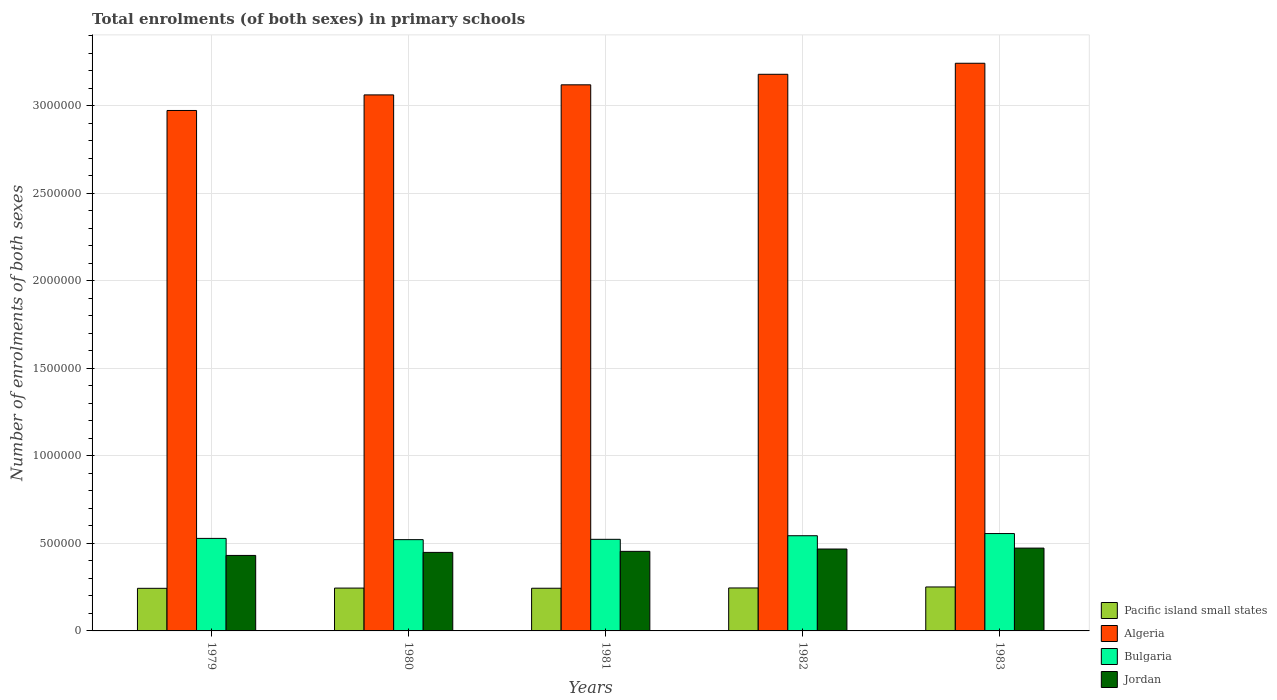How many groups of bars are there?
Make the answer very short. 5. Are the number of bars per tick equal to the number of legend labels?
Ensure brevity in your answer.  Yes. How many bars are there on the 4th tick from the left?
Make the answer very short. 4. How many bars are there on the 4th tick from the right?
Your response must be concise. 4. What is the label of the 5th group of bars from the left?
Your answer should be very brief. 1983. In how many cases, is the number of bars for a given year not equal to the number of legend labels?
Offer a terse response. 0. What is the number of enrolments in primary schools in Bulgaria in 1981?
Ensure brevity in your answer.  5.23e+05. Across all years, what is the maximum number of enrolments in primary schools in Algeria?
Your response must be concise. 3.24e+06. Across all years, what is the minimum number of enrolments in primary schools in Pacific island small states?
Your response must be concise. 2.43e+05. In which year was the number of enrolments in primary schools in Algeria minimum?
Offer a terse response. 1979. What is the total number of enrolments in primary schools in Algeria in the graph?
Offer a very short reply. 1.56e+07. What is the difference between the number of enrolments in primary schools in Algeria in 1981 and that in 1982?
Provide a succinct answer. -6.01e+04. What is the difference between the number of enrolments in primary schools in Jordan in 1982 and the number of enrolments in primary schools in Algeria in 1980?
Provide a succinct answer. -2.59e+06. What is the average number of enrolments in primary schools in Algeria per year?
Your answer should be compact. 3.11e+06. In the year 1980, what is the difference between the number of enrolments in primary schools in Jordan and number of enrolments in primary schools in Pacific island small states?
Make the answer very short. 2.04e+05. What is the ratio of the number of enrolments in primary schools in Jordan in 1979 to that in 1983?
Offer a very short reply. 0.91. Is the number of enrolments in primary schools in Algeria in 1981 less than that in 1983?
Provide a short and direct response. Yes. What is the difference between the highest and the second highest number of enrolments in primary schools in Jordan?
Provide a succinct answer. 5331. What is the difference between the highest and the lowest number of enrolments in primary schools in Pacific island small states?
Provide a succinct answer. 7791.62. In how many years, is the number of enrolments in primary schools in Bulgaria greater than the average number of enrolments in primary schools in Bulgaria taken over all years?
Give a very brief answer. 2. Is the sum of the number of enrolments in primary schools in Jordan in 1981 and 1982 greater than the maximum number of enrolments in primary schools in Bulgaria across all years?
Offer a very short reply. Yes. What does the 2nd bar from the left in 1980 represents?
Provide a succinct answer. Algeria. What does the 4th bar from the right in 1983 represents?
Offer a terse response. Pacific island small states. How many bars are there?
Your answer should be very brief. 20. Are all the bars in the graph horizontal?
Make the answer very short. No. What is the difference between two consecutive major ticks on the Y-axis?
Keep it short and to the point. 5.00e+05. Does the graph contain any zero values?
Your answer should be very brief. No. Where does the legend appear in the graph?
Ensure brevity in your answer.  Bottom right. How many legend labels are there?
Offer a terse response. 4. How are the legend labels stacked?
Your answer should be compact. Vertical. What is the title of the graph?
Make the answer very short. Total enrolments (of both sexes) in primary schools. What is the label or title of the X-axis?
Your answer should be compact. Years. What is the label or title of the Y-axis?
Your answer should be compact. Number of enrolments of both sexes. What is the Number of enrolments of both sexes of Pacific island small states in 1979?
Keep it short and to the point. 2.43e+05. What is the Number of enrolments of both sexes in Algeria in 1979?
Your answer should be compact. 2.97e+06. What is the Number of enrolments of both sexes of Bulgaria in 1979?
Offer a terse response. 5.28e+05. What is the Number of enrolments of both sexes in Jordan in 1979?
Provide a succinct answer. 4.31e+05. What is the Number of enrolments of both sexes in Pacific island small states in 1980?
Your response must be concise. 2.45e+05. What is the Number of enrolments of both sexes of Algeria in 1980?
Your answer should be compact. 3.06e+06. What is the Number of enrolments of both sexes in Bulgaria in 1980?
Ensure brevity in your answer.  5.21e+05. What is the Number of enrolments of both sexes in Jordan in 1980?
Provide a succinct answer. 4.48e+05. What is the Number of enrolments of both sexes of Pacific island small states in 1981?
Your response must be concise. 2.44e+05. What is the Number of enrolments of both sexes of Algeria in 1981?
Offer a terse response. 3.12e+06. What is the Number of enrolments of both sexes in Bulgaria in 1981?
Your response must be concise. 5.23e+05. What is the Number of enrolments of both sexes of Jordan in 1981?
Your response must be concise. 4.54e+05. What is the Number of enrolments of both sexes of Pacific island small states in 1982?
Provide a succinct answer. 2.45e+05. What is the Number of enrolments of both sexes of Algeria in 1982?
Provide a succinct answer. 3.18e+06. What is the Number of enrolments of both sexes of Bulgaria in 1982?
Your response must be concise. 5.44e+05. What is the Number of enrolments of both sexes in Jordan in 1982?
Your answer should be very brief. 4.68e+05. What is the Number of enrolments of both sexes in Pacific island small states in 1983?
Provide a succinct answer. 2.51e+05. What is the Number of enrolments of both sexes in Algeria in 1983?
Make the answer very short. 3.24e+06. What is the Number of enrolments of both sexes in Bulgaria in 1983?
Provide a succinct answer. 5.56e+05. What is the Number of enrolments of both sexes in Jordan in 1983?
Keep it short and to the point. 4.73e+05. Across all years, what is the maximum Number of enrolments of both sexes of Pacific island small states?
Offer a terse response. 2.51e+05. Across all years, what is the maximum Number of enrolments of both sexes of Algeria?
Your response must be concise. 3.24e+06. Across all years, what is the maximum Number of enrolments of both sexes in Bulgaria?
Offer a terse response. 5.56e+05. Across all years, what is the maximum Number of enrolments of both sexes in Jordan?
Your answer should be very brief. 4.73e+05. Across all years, what is the minimum Number of enrolments of both sexes in Pacific island small states?
Your answer should be very brief. 2.43e+05. Across all years, what is the minimum Number of enrolments of both sexes in Algeria?
Your response must be concise. 2.97e+06. Across all years, what is the minimum Number of enrolments of both sexes of Bulgaria?
Your response must be concise. 5.21e+05. Across all years, what is the minimum Number of enrolments of both sexes of Jordan?
Make the answer very short. 4.31e+05. What is the total Number of enrolments of both sexes of Pacific island small states in the graph?
Offer a very short reply. 1.23e+06. What is the total Number of enrolments of both sexes of Algeria in the graph?
Make the answer very short. 1.56e+07. What is the total Number of enrolments of both sexes of Bulgaria in the graph?
Your answer should be very brief. 2.67e+06. What is the total Number of enrolments of both sexes in Jordan in the graph?
Offer a very short reply. 2.27e+06. What is the difference between the Number of enrolments of both sexes in Pacific island small states in 1979 and that in 1980?
Your answer should be compact. -1357.97. What is the difference between the Number of enrolments of both sexes of Algeria in 1979 and that in 1980?
Keep it short and to the point. -8.90e+04. What is the difference between the Number of enrolments of both sexes of Bulgaria in 1979 and that in 1980?
Offer a very short reply. 7083. What is the difference between the Number of enrolments of both sexes in Jordan in 1979 and that in 1980?
Provide a short and direct response. -1.73e+04. What is the difference between the Number of enrolments of both sexes of Pacific island small states in 1979 and that in 1981?
Provide a succinct answer. -450.34. What is the difference between the Number of enrolments of both sexes in Algeria in 1979 and that in 1981?
Offer a terse response. -1.47e+05. What is the difference between the Number of enrolments of both sexes in Bulgaria in 1979 and that in 1981?
Provide a succinct answer. 5206. What is the difference between the Number of enrolments of both sexes in Jordan in 1979 and that in 1981?
Make the answer very short. -2.33e+04. What is the difference between the Number of enrolments of both sexes in Pacific island small states in 1979 and that in 1982?
Offer a terse response. -2059.73. What is the difference between the Number of enrolments of both sexes in Algeria in 1979 and that in 1982?
Your answer should be very brief. -2.07e+05. What is the difference between the Number of enrolments of both sexes of Bulgaria in 1979 and that in 1982?
Give a very brief answer. -1.53e+04. What is the difference between the Number of enrolments of both sexes in Jordan in 1979 and that in 1982?
Your answer should be very brief. -3.66e+04. What is the difference between the Number of enrolments of both sexes of Pacific island small states in 1979 and that in 1983?
Ensure brevity in your answer.  -7791.62. What is the difference between the Number of enrolments of both sexes in Algeria in 1979 and that in 1983?
Give a very brief answer. -2.70e+05. What is the difference between the Number of enrolments of both sexes of Bulgaria in 1979 and that in 1983?
Provide a succinct answer. -2.77e+04. What is the difference between the Number of enrolments of both sexes in Jordan in 1979 and that in 1983?
Provide a short and direct response. -4.19e+04. What is the difference between the Number of enrolments of both sexes in Pacific island small states in 1980 and that in 1981?
Your answer should be very brief. 907.62. What is the difference between the Number of enrolments of both sexes in Algeria in 1980 and that in 1981?
Your answer should be very brief. -5.76e+04. What is the difference between the Number of enrolments of both sexes in Bulgaria in 1980 and that in 1981?
Provide a short and direct response. -1877. What is the difference between the Number of enrolments of both sexes of Jordan in 1980 and that in 1981?
Ensure brevity in your answer.  -5980. What is the difference between the Number of enrolments of both sexes in Pacific island small states in 1980 and that in 1982?
Make the answer very short. -701.77. What is the difference between the Number of enrolments of both sexes in Algeria in 1980 and that in 1982?
Provide a succinct answer. -1.18e+05. What is the difference between the Number of enrolments of both sexes of Bulgaria in 1980 and that in 1982?
Your answer should be very brief. -2.24e+04. What is the difference between the Number of enrolments of both sexes in Jordan in 1980 and that in 1982?
Keep it short and to the point. -1.93e+04. What is the difference between the Number of enrolments of both sexes in Pacific island small states in 1980 and that in 1983?
Your response must be concise. -6433.66. What is the difference between the Number of enrolments of both sexes in Algeria in 1980 and that in 1983?
Your answer should be very brief. -1.81e+05. What is the difference between the Number of enrolments of both sexes of Bulgaria in 1980 and that in 1983?
Provide a succinct answer. -3.48e+04. What is the difference between the Number of enrolments of both sexes of Jordan in 1980 and that in 1983?
Your answer should be compact. -2.46e+04. What is the difference between the Number of enrolments of both sexes of Pacific island small states in 1981 and that in 1982?
Provide a succinct answer. -1609.39. What is the difference between the Number of enrolments of both sexes in Algeria in 1981 and that in 1982?
Make the answer very short. -6.01e+04. What is the difference between the Number of enrolments of both sexes of Bulgaria in 1981 and that in 1982?
Provide a succinct answer. -2.05e+04. What is the difference between the Number of enrolments of both sexes in Jordan in 1981 and that in 1982?
Make the answer very short. -1.33e+04. What is the difference between the Number of enrolments of both sexes in Pacific island small states in 1981 and that in 1983?
Offer a very short reply. -7341.28. What is the difference between the Number of enrolments of both sexes of Algeria in 1981 and that in 1983?
Make the answer very short. -1.23e+05. What is the difference between the Number of enrolments of both sexes in Bulgaria in 1981 and that in 1983?
Offer a very short reply. -3.29e+04. What is the difference between the Number of enrolments of both sexes of Jordan in 1981 and that in 1983?
Your response must be concise. -1.86e+04. What is the difference between the Number of enrolments of both sexes in Pacific island small states in 1982 and that in 1983?
Ensure brevity in your answer.  -5731.89. What is the difference between the Number of enrolments of both sexes of Algeria in 1982 and that in 1983?
Make the answer very short. -6.30e+04. What is the difference between the Number of enrolments of both sexes of Bulgaria in 1982 and that in 1983?
Ensure brevity in your answer.  -1.24e+04. What is the difference between the Number of enrolments of both sexes in Jordan in 1982 and that in 1983?
Provide a short and direct response. -5331. What is the difference between the Number of enrolments of both sexes of Pacific island small states in 1979 and the Number of enrolments of both sexes of Algeria in 1980?
Your answer should be compact. -2.82e+06. What is the difference between the Number of enrolments of both sexes of Pacific island small states in 1979 and the Number of enrolments of both sexes of Bulgaria in 1980?
Provide a succinct answer. -2.78e+05. What is the difference between the Number of enrolments of both sexes in Pacific island small states in 1979 and the Number of enrolments of both sexes in Jordan in 1980?
Provide a short and direct response. -2.05e+05. What is the difference between the Number of enrolments of both sexes of Algeria in 1979 and the Number of enrolments of both sexes of Bulgaria in 1980?
Provide a succinct answer. 2.45e+06. What is the difference between the Number of enrolments of both sexes of Algeria in 1979 and the Number of enrolments of both sexes of Jordan in 1980?
Give a very brief answer. 2.52e+06. What is the difference between the Number of enrolments of both sexes of Bulgaria in 1979 and the Number of enrolments of both sexes of Jordan in 1980?
Provide a short and direct response. 8.00e+04. What is the difference between the Number of enrolments of both sexes of Pacific island small states in 1979 and the Number of enrolments of both sexes of Algeria in 1981?
Provide a short and direct response. -2.88e+06. What is the difference between the Number of enrolments of both sexes of Pacific island small states in 1979 and the Number of enrolments of both sexes of Bulgaria in 1981?
Provide a short and direct response. -2.80e+05. What is the difference between the Number of enrolments of both sexes of Pacific island small states in 1979 and the Number of enrolments of both sexes of Jordan in 1981?
Your answer should be compact. -2.11e+05. What is the difference between the Number of enrolments of both sexes in Algeria in 1979 and the Number of enrolments of both sexes in Bulgaria in 1981?
Your answer should be very brief. 2.45e+06. What is the difference between the Number of enrolments of both sexes of Algeria in 1979 and the Number of enrolments of both sexes of Jordan in 1981?
Make the answer very short. 2.52e+06. What is the difference between the Number of enrolments of both sexes in Bulgaria in 1979 and the Number of enrolments of both sexes in Jordan in 1981?
Give a very brief answer. 7.40e+04. What is the difference between the Number of enrolments of both sexes of Pacific island small states in 1979 and the Number of enrolments of both sexes of Algeria in 1982?
Provide a short and direct response. -2.94e+06. What is the difference between the Number of enrolments of both sexes of Pacific island small states in 1979 and the Number of enrolments of both sexes of Bulgaria in 1982?
Provide a short and direct response. -3.00e+05. What is the difference between the Number of enrolments of both sexes in Pacific island small states in 1979 and the Number of enrolments of both sexes in Jordan in 1982?
Offer a very short reply. -2.24e+05. What is the difference between the Number of enrolments of both sexes of Algeria in 1979 and the Number of enrolments of both sexes of Bulgaria in 1982?
Your response must be concise. 2.43e+06. What is the difference between the Number of enrolments of both sexes of Algeria in 1979 and the Number of enrolments of both sexes of Jordan in 1982?
Offer a terse response. 2.50e+06. What is the difference between the Number of enrolments of both sexes in Bulgaria in 1979 and the Number of enrolments of both sexes in Jordan in 1982?
Ensure brevity in your answer.  6.07e+04. What is the difference between the Number of enrolments of both sexes of Pacific island small states in 1979 and the Number of enrolments of both sexes of Algeria in 1983?
Your answer should be very brief. -3.00e+06. What is the difference between the Number of enrolments of both sexes of Pacific island small states in 1979 and the Number of enrolments of both sexes of Bulgaria in 1983?
Your response must be concise. -3.13e+05. What is the difference between the Number of enrolments of both sexes of Pacific island small states in 1979 and the Number of enrolments of both sexes of Jordan in 1983?
Ensure brevity in your answer.  -2.30e+05. What is the difference between the Number of enrolments of both sexes in Algeria in 1979 and the Number of enrolments of both sexes in Bulgaria in 1983?
Keep it short and to the point. 2.42e+06. What is the difference between the Number of enrolments of both sexes of Algeria in 1979 and the Number of enrolments of both sexes of Jordan in 1983?
Ensure brevity in your answer.  2.50e+06. What is the difference between the Number of enrolments of both sexes in Bulgaria in 1979 and the Number of enrolments of both sexes in Jordan in 1983?
Offer a terse response. 5.53e+04. What is the difference between the Number of enrolments of both sexes of Pacific island small states in 1980 and the Number of enrolments of both sexes of Algeria in 1981?
Ensure brevity in your answer.  -2.87e+06. What is the difference between the Number of enrolments of both sexes in Pacific island small states in 1980 and the Number of enrolments of both sexes in Bulgaria in 1981?
Provide a short and direct response. -2.79e+05. What is the difference between the Number of enrolments of both sexes of Pacific island small states in 1980 and the Number of enrolments of both sexes of Jordan in 1981?
Your response must be concise. -2.10e+05. What is the difference between the Number of enrolments of both sexes of Algeria in 1980 and the Number of enrolments of both sexes of Bulgaria in 1981?
Your answer should be compact. 2.54e+06. What is the difference between the Number of enrolments of both sexes of Algeria in 1980 and the Number of enrolments of both sexes of Jordan in 1981?
Offer a very short reply. 2.61e+06. What is the difference between the Number of enrolments of both sexes in Bulgaria in 1980 and the Number of enrolments of both sexes in Jordan in 1981?
Provide a short and direct response. 6.69e+04. What is the difference between the Number of enrolments of both sexes of Pacific island small states in 1980 and the Number of enrolments of both sexes of Algeria in 1982?
Offer a terse response. -2.93e+06. What is the difference between the Number of enrolments of both sexes of Pacific island small states in 1980 and the Number of enrolments of both sexes of Bulgaria in 1982?
Keep it short and to the point. -2.99e+05. What is the difference between the Number of enrolments of both sexes of Pacific island small states in 1980 and the Number of enrolments of both sexes of Jordan in 1982?
Make the answer very short. -2.23e+05. What is the difference between the Number of enrolments of both sexes in Algeria in 1980 and the Number of enrolments of both sexes in Bulgaria in 1982?
Your answer should be very brief. 2.52e+06. What is the difference between the Number of enrolments of both sexes of Algeria in 1980 and the Number of enrolments of both sexes of Jordan in 1982?
Make the answer very short. 2.59e+06. What is the difference between the Number of enrolments of both sexes in Bulgaria in 1980 and the Number of enrolments of both sexes in Jordan in 1982?
Your response must be concise. 5.36e+04. What is the difference between the Number of enrolments of both sexes in Pacific island small states in 1980 and the Number of enrolments of both sexes in Algeria in 1983?
Provide a succinct answer. -3.00e+06. What is the difference between the Number of enrolments of both sexes of Pacific island small states in 1980 and the Number of enrolments of both sexes of Bulgaria in 1983?
Give a very brief answer. -3.11e+05. What is the difference between the Number of enrolments of both sexes in Pacific island small states in 1980 and the Number of enrolments of both sexes in Jordan in 1983?
Provide a succinct answer. -2.28e+05. What is the difference between the Number of enrolments of both sexes in Algeria in 1980 and the Number of enrolments of both sexes in Bulgaria in 1983?
Keep it short and to the point. 2.51e+06. What is the difference between the Number of enrolments of both sexes in Algeria in 1980 and the Number of enrolments of both sexes in Jordan in 1983?
Your answer should be very brief. 2.59e+06. What is the difference between the Number of enrolments of both sexes of Bulgaria in 1980 and the Number of enrolments of both sexes of Jordan in 1983?
Your answer should be very brief. 4.83e+04. What is the difference between the Number of enrolments of both sexes of Pacific island small states in 1981 and the Number of enrolments of both sexes of Algeria in 1982?
Offer a terse response. -2.94e+06. What is the difference between the Number of enrolments of both sexes in Pacific island small states in 1981 and the Number of enrolments of both sexes in Bulgaria in 1982?
Your answer should be very brief. -3.00e+05. What is the difference between the Number of enrolments of both sexes of Pacific island small states in 1981 and the Number of enrolments of both sexes of Jordan in 1982?
Give a very brief answer. -2.24e+05. What is the difference between the Number of enrolments of both sexes in Algeria in 1981 and the Number of enrolments of both sexes in Bulgaria in 1982?
Your answer should be compact. 2.58e+06. What is the difference between the Number of enrolments of both sexes in Algeria in 1981 and the Number of enrolments of both sexes in Jordan in 1982?
Your response must be concise. 2.65e+06. What is the difference between the Number of enrolments of both sexes in Bulgaria in 1981 and the Number of enrolments of both sexes in Jordan in 1982?
Ensure brevity in your answer.  5.55e+04. What is the difference between the Number of enrolments of both sexes in Pacific island small states in 1981 and the Number of enrolments of both sexes in Algeria in 1983?
Provide a short and direct response. -3.00e+06. What is the difference between the Number of enrolments of both sexes of Pacific island small states in 1981 and the Number of enrolments of both sexes of Bulgaria in 1983?
Offer a very short reply. -3.12e+05. What is the difference between the Number of enrolments of both sexes in Pacific island small states in 1981 and the Number of enrolments of both sexes in Jordan in 1983?
Provide a short and direct response. -2.29e+05. What is the difference between the Number of enrolments of both sexes of Algeria in 1981 and the Number of enrolments of both sexes of Bulgaria in 1983?
Offer a very short reply. 2.56e+06. What is the difference between the Number of enrolments of both sexes of Algeria in 1981 and the Number of enrolments of both sexes of Jordan in 1983?
Your answer should be very brief. 2.65e+06. What is the difference between the Number of enrolments of both sexes in Bulgaria in 1981 and the Number of enrolments of both sexes in Jordan in 1983?
Offer a very short reply. 5.01e+04. What is the difference between the Number of enrolments of both sexes in Pacific island small states in 1982 and the Number of enrolments of both sexes in Algeria in 1983?
Make the answer very short. -3.00e+06. What is the difference between the Number of enrolments of both sexes in Pacific island small states in 1982 and the Number of enrolments of both sexes in Bulgaria in 1983?
Your answer should be compact. -3.11e+05. What is the difference between the Number of enrolments of both sexes in Pacific island small states in 1982 and the Number of enrolments of both sexes in Jordan in 1983?
Your response must be concise. -2.28e+05. What is the difference between the Number of enrolments of both sexes of Algeria in 1982 and the Number of enrolments of both sexes of Bulgaria in 1983?
Provide a succinct answer. 2.62e+06. What is the difference between the Number of enrolments of both sexes in Algeria in 1982 and the Number of enrolments of both sexes in Jordan in 1983?
Your answer should be compact. 2.71e+06. What is the difference between the Number of enrolments of both sexes in Bulgaria in 1982 and the Number of enrolments of both sexes in Jordan in 1983?
Keep it short and to the point. 7.06e+04. What is the average Number of enrolments of both sexes in Pacific island small states per year?
Ensure brevity in your answer.  2.46e+05. What is the average Number of enrolments of both sexes of Algeria per year?
Keep it short and to the point. 3.11e+06. What is the average Number of enrolments of both sexes of Bulgaria per year?
Provide a short and direct response. 5.34e+05. What is the average Number of enrolments of both sexes of Jordan per year?
Give a very brief answer. 4.55e+05. In the year 1979, what is the difference between the Number of enrolments of both sexes of Pacific island small states and Number of enrolments of both sexes of Algeria?
Provide a short and direct response. -2.73e+06. In the year 1979, what is the difference between the Number of enrolments of both sexes of Pacific island small states and Number of enrolments of both sexes of Bulgaria?
Offer a very short reply. -2.85e+05. In the year 1979, what is the difference between the Number of enrolments of both sexes of Pacific island small states and Number of enrolments of both sexes of Jordan?
Provide a succinct answer. -1.88e+05. In the year 1979, what is the difference between the Number of enrolments of both sexes of Algeria and Number of enrolments of both sexes of Bulgaria?
Your answer should be very brief. 2.44e+06. In the year 1979, what is the difference between the Number of enrolments of both sexes of Algeria and Number of enrolments of both sexes of Jordan?
Make the answer very short. 2.54e+06. In the year 1979, what is the difference between the Number of enrolments of both sexes in Bulgaria and Number of enrolments of both sexes in Jordan?
Keep it short and to the point. 9.73e+04. In the year 1980, what is the difference between the Number of enrolments of both sexes in Pacific island small states and Number of enrolments of both sexes in Algeria?
Provide a short and direct response. -2.82e+06. In the year 1980, what is the difference between the Number of enrolments of both sexes of Pacific island small states and Number of enrolments of both sexes of Bulgaria?
Provide a succinct answer. -2.77e+05. In the year 1980, what is the difference between the Number of enrolments of both sexes of Pacific island small states and Number of enrolments of both sexes of Jordan?
Your answer should be compact. -2.04e+05. In the year 1980, what is the difference between the Number of enrolments of both sexes of Algeria and Number of enrolments of both sexes of Bulgaria?
Give a very brief answer. 2.54e+06. In the year 1980, what is the difference between the Number of enrolments of both sexes in Algeria and Number of enrolments of both sexes in Jordan?
Your answer should be very brief. 2.61e+06. In the year 1980, what is the difference between the Number of enrolments of both sexes of Bulgaria and Number of enrolments of both sexes of Jordan?
Keep it short and to the point. 7.29e+04. In the year 1981, what is the difference between the Number of enrolments of both sexes in Pacific island small states and Number of enrolments of both sexes in Algeria?
Ensure brevity in your answer.  -2.88e+06. In the year 1981, what is the difference between the Number of enrolments of both sexes of Pacific island small states and Number of enrolments of both sexes of Bulgaria?
Offer a terse response. -2.79e+05. In the year 1981, what is the difference between the Number of enrolments of both sexes of Pacific island small states and Number of enrolments of both sexes of Jordan?
Offer a very short reply. -2.11e+05. In the year 1981, what is the difference between the Number of enrolments of both sexes in Algeria and Number of enrolments of both sexes in Bulgaria?
Keep it short and to the point. 2.60e+06. In the year 1981, what is the difference between the Number of enrolments of both sexes of Algeria and Number of enrolments of both sexes of Jordan?
Give a very brief answer. 2.66e+06. In the year 1981, what is the difference between the Number of enrolments of both sexes of Bulgaria and Number of enrolments of both sexes of Jordan?
Provide a short and direct response. 6.88e+04. In the year 1982, what is the difference between the Number of enrolments of both sexes of Pacific island small states and Number of enrolments of both sexes of Algeria?
Provide a succinct answer. -2.93e+06. In the year 1982, what is the difference between the Number of enrolments of both sexes of Pacific island small states and Number of enrolments of both sexes of Bulgaria?
Offer a very short reply. -2.98e+05. In the year 1982, what is the difference between the Number of enrolments of both sexes of Pacific island small states and Number of enrolments of both sexes of Jordan?
Make the answer very short. -2.22e+05. In the year 1982, what is the difference between the Number of enrolments of both sexes of Algeria and Number of enrolments of both sexes of Bulgaria?
Your response must be concise. 2.64e+06. In the year 1982, what is the difference between the Number of enrolments of both sexes in Algeria and Number of enrolments of both sexes in Jordan?
Give a very brief answer. 2.71e+06. In the year 1982, what is the difference between the Number of enrolments of both sexes in Bulgaria and Number of enrolments of both sexes in Jordan?
Your answer should be compact. 7.59e+04. In the year 1983, what is the difference between the Number of enrolments of both sexes in Pacific island small states and Number of enrolments of both sexes in Algeria?
Your answer should be very brief. -2.99e+06. In the year 1983, what is the difference between the Number of enrolments of both sexes in Pacific island small states and Number of enrolments of both sexes in Bulgaria?
Keep it short and to the point. -3.05e+05. In the year 1983, what is the difference between the Number of enrolments of both sexes of Pacific island small states and Number of enrolments of both sexes of Jordan?
Give a very brief answer. -2.22e+05. In the year 1983, what is the difference between the Number of enrolments of both sexes in Algeria and Number of enrolments of both sexes in Bulgaria?
Give a very brief answer. 2.69e+06. In the year 1983, what is the difference between the Number of enrolments of both sexes of Algeria and Number of enrolments of both sexes of Jordan?
Keep it short and to the point. 2.77e+06. In the year 1983, what is the difference between the Number of enrolments of both sexes in Bulgaria and Number of enrolments of both sexes in Jordan?
Your answer should be compact. 8.30e+04. What is the ratio of the Number of enrolments of both sexes in Algeria in 1979 to that in 1980?
Make the answer very short. 0.97. What is the ratio of the Number of enrolments of both sexes of Bulgaria in 1979 to that in 1980?
Offer a terse response. 1.01. What is the ratio of the Number of enrolments of both sexes in Jordan in 1979 to that in 1980?
Your response must be concise. 0.96. What is the ratio of the Number of enrolments of both sexes of Algeria in 1979 to that in 1981?
Make the answer very short. 0.95. What is the ratio of the Number of enrolments of both sexes in Jordan in 1979 to that in 1981?
Offer a terse response. 0.95. What is the ratio of the Number of enrolments of both sexes of Pacific island small states in 1979 to that in 1982?
Your answer should be compact. 0.99. What is the ratio of the Number of enrolments of both sexes in Algeria in 1979 to that in 1982?
Give a very brief answer. 0.94. What is the ratio of the Number of enrolments of both sexes of Bulgaria in 1979 to that in 1982?
Keep it short and to the point. 0.97. What is the ratio of the Number of enrolments of both sexes of Jordan in 1979 to that in 1982?
Give a very brief answer. 0.92. What is the ratio of the Number of enrolments of both sexes of Pacific island small states in 1979 to that in 1983?
Provide a succinct answer. 0.97. What is the ratio of the Number of enrolments of both sexes in Algeria in 1979 to that in 1983?
Keep it short and to the point. 0.92. What is the ratio of the Number of enrolments of both sexes of Bulgaria in 1979 to that in 1983?
Your answer should be compact. 0.95. What is the ratio of the Number of enrolments of both sexes in Jordan in 1979 to that in 1983?
Keep it short and to the point. 0.91. What is the ratio of the Number of enrolments of both sexes in Pacific island small states in 1980 to that in 1981?
Your response must be concise. 1. What is the ratio of the Number of enrolments of both sexes of Algeria in 1980 to that in 1981?
Keep it short and to the point. 0.98. What is the ratio of the Number of enrolments of both sexes of Bulgaria in 1980 to that in 1981?
Keep it short and to the point. 1. What is the ratio of the Number of enrolments of both sexes of Jordan in 1980 to that in 1981?
Provide a short and direct response. 0.99. What is the ratio of the Number of enrolments of both sexes in Pacific island small states in 1980 to that in 1982?
Offer a terse response. 1. What is the ratio of the Number of enrolments of both sexes in Bulgaria in 1980 to that in 1982?
Provide a succinct answer. 0.96. What is the ratio of the Number of enrolments of both sexes of Jordan in 1980 to that in 1982?
Your answer should be compact. 0.96. What is the ratio of the Number of enrolments of both sexes of Pacific island small states in 1980 to that in 1983?
Give a very brief answer. 0.97. What is the ratio of the Number of enrolments of both sexes of Algeria in 1980 to that in 1983?
Make the answer very short. 0.94. What is the ratio of the Number of enrolments of both sexes in Jordan in 1980 to that in 1983?
Keep it short and to the point. 0.95. What is the ratio of the Number of enrolments of both sexes in Pacific island small states in 1981 to that in 1982?
Make the answer very short. 0.99. What is the ratio of the Number of enrolments of both sexes in Algeria in 1981 to that in 1982?
Ensure brevity in your answer.  0.98. What is the ratio of the Number of enrolments of both sexes of Bulgaria in 1981 to that in 1982?
Your answer should be compact. 0.96. What is the ratio of the Number of enrolments of both sexes of Jordan in 1981 to that in 1982?
Offer a terse response. 0.97. What is the ratio of the Number of enrolments of both sexes in Pacific island small states in 1981 to that in 1983?
Provide a short and direct response. 0.97. What is the ratio of the Number of enrolments of both sexes of Bulgaria in 1981 to that in 1983?
Provide a succinct answer. 0.94. What is the ratio of the Number of enrolments of both sexes of Jordan in 1981 to that in 1983?
Keep it short and to the point. 0.96. What is the ratio of the Number of enrolments of both sexes of Pacific island small states in 1982 to that in 1983?
Ensure brevity in your answer.  0.98. What is the ratio of the Number of enrolments of both sexes in Algeria in 1982 to that in 1983?
Make the answer very short. 0.98. What is the ratio of the Number of enrolments of both sexes in Bulgaria in 1982 to that in 1983?
Offer a very short reply. 0.98. What is the ratio of the Number of enrolments of both sexes of Jordan in 1982 to that in 1983?
Make the answer very short. 0.99. What is the difference between the highest and the second highest Number of enrolments of both sexes in Pacific island small states?
Provide a short and direct response. 5731.89. What is the difference between the highest and the second highest Number of enrolments of both sexes in Algeria?
Your answer should be compact. 6.30e+04. What is the difference between the highest and the second highest Number of enrolments of both sexes in Bulgaria?
Keep it short and to the point. 1.24e+04. What is the difference between the highest and the second highest Number of enrolments of both sexes of Jordan?
Provide a short and direct response. 5331. What is the difference between the highest and the lowest Number of enrolments of both sexes in Pacific island small states?
Your response must be concise. 7791.62. What is the difference between the highest and the lowest Number of enrolments of both sexes of Algeria?
Provide a succinct answer. 2.70e+05. What is the difference between the highest and the lowest Number of enrolments of both sexes in Bulgaria?
Keep it short and to the point. 3.48e+04. What is the difference between the highest and the lowest Number of enrolments of both sexes of Jordan?
Ensure brevity in your answer.  4.19e+04. 